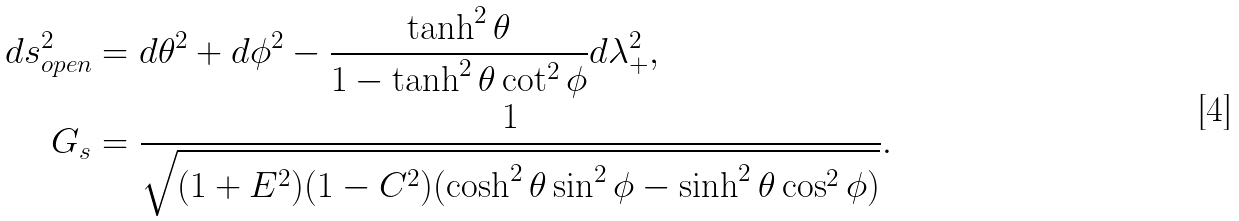<formula> <loc_0><loc_0><loc_500><loc_500>d s _ { o p e n } ^ { 2 } & = d \theta ^ { 2 } + d \phi ^ { 2 } - \frac { \tanh ^ { 2 } \theta } { 1 - \tanh ^ { 2 } \theta \cot ^ { 2 } \phi } d \lambda _ { + } ^ { 2 } , \\ G _ { s } & = \frac { 1 } { \sqrt { ( 1 + E ^ { 2 } ) ( 1 - C ^ { 2 } ) ( \cosh ^ { 2 } \theta \sin ^ { 2 } \phi - \sinh ^ { 2 } \theta \cos ^ { 2 } \phi ) } } .</formula> 